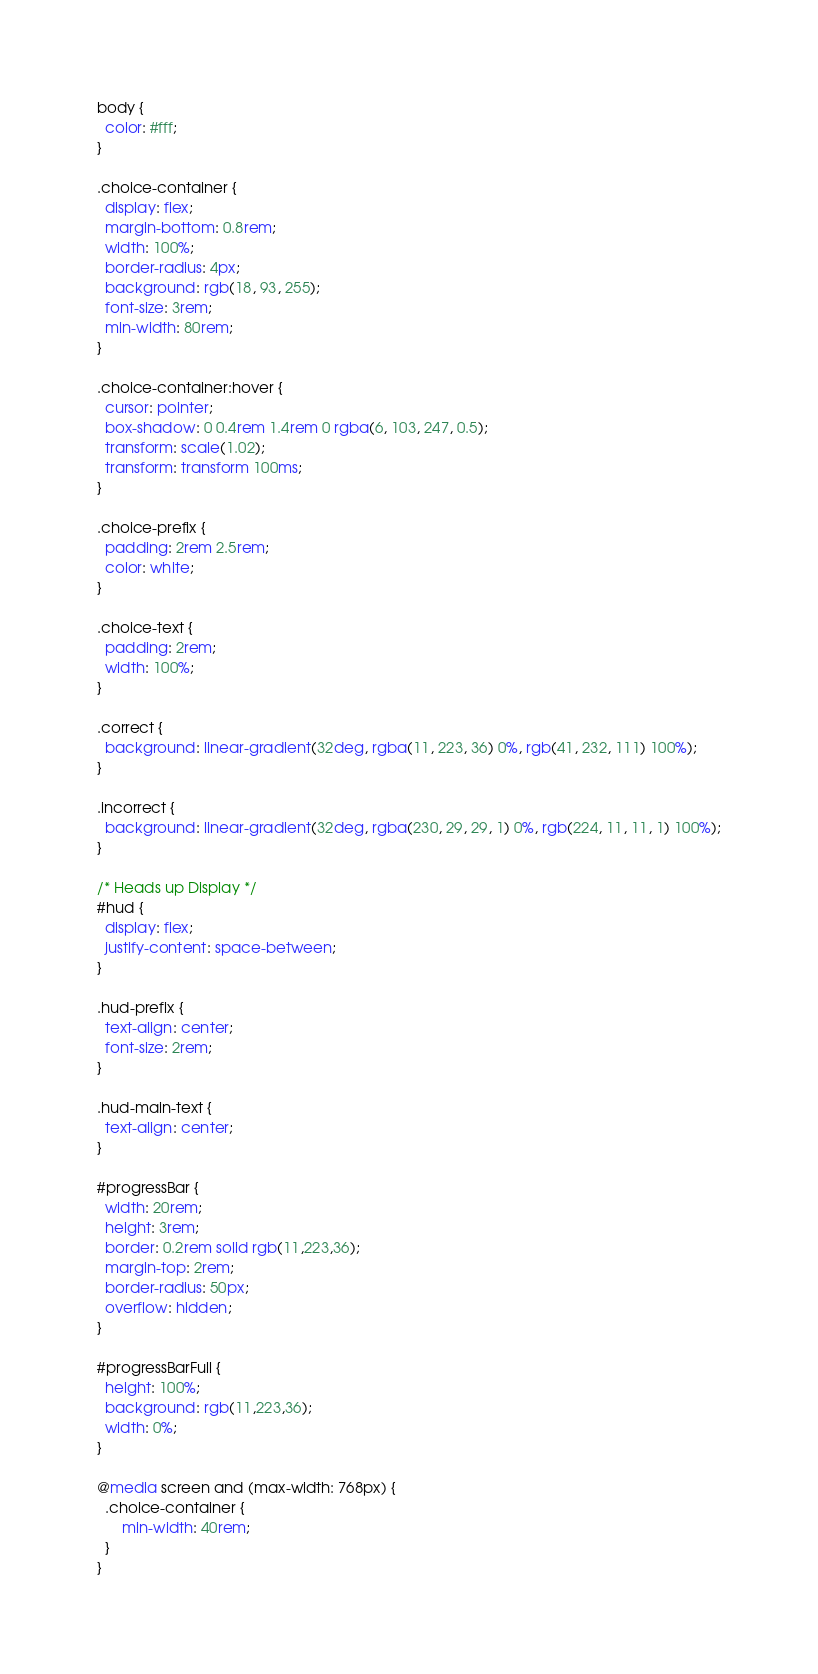Convert code to text. <code><loc_0><loc_0><loc_500><loc_500><_CSS_>body {
  color: #fff;
}

.choice-container {
  display: flex;
  margin-bottom: 0.8rem;
  width: 100%;
  border-radius: 4px;
  background: rgb(18, 93, 255);
  font-size: 3rem;
  min-width: 80rem;
}

.choice-container:hover {
  cursor: pointer;
  box-shadow: 0 0.4rem 1.4rem 0 rgba(6, 103, 247, 0.5);
  transform: scale(1.02);
  transform: transform 100ms;
}

.choice-prefix {
  padding: 2rem 2.5rem;
  color: white;
}

.choice-text {
  padding: 2rem;
  width: 100%;
}

.correct {
  background: linear-gradient(32deg, rgba(11, 223, 36) 0%, rgb(41, 232, 111) 100%);
}

.incorrect {
  background: linear-gradient(32deg, rgba(230, 29, 29, 1) 0%, rgb(224, 11, 11, 1) 100%);
}

/* Heads up Display */
#hud {
  display: flex;
  justify-content: space-between;
}

.hud-prefix {
  text-align: center;
  font-size: 2rem;
}

.hud-main-text {
  text-align: center;
}

#progressBar {
  width: 20rem;
  height: 3rem;
  border: 0.2rem solid rgb(11,223,36);
  margin-top: 2rem;
  border-radius: 50px;
  overflow: hidden;
}

#progressBarFull {
  height: 100%;
  background: rgb(11,223,36);
  width: 0%;
}

@media screen and (max-width: 768px) {
  .choice-container {
      min-width: 40rem;
  }
}</code> 